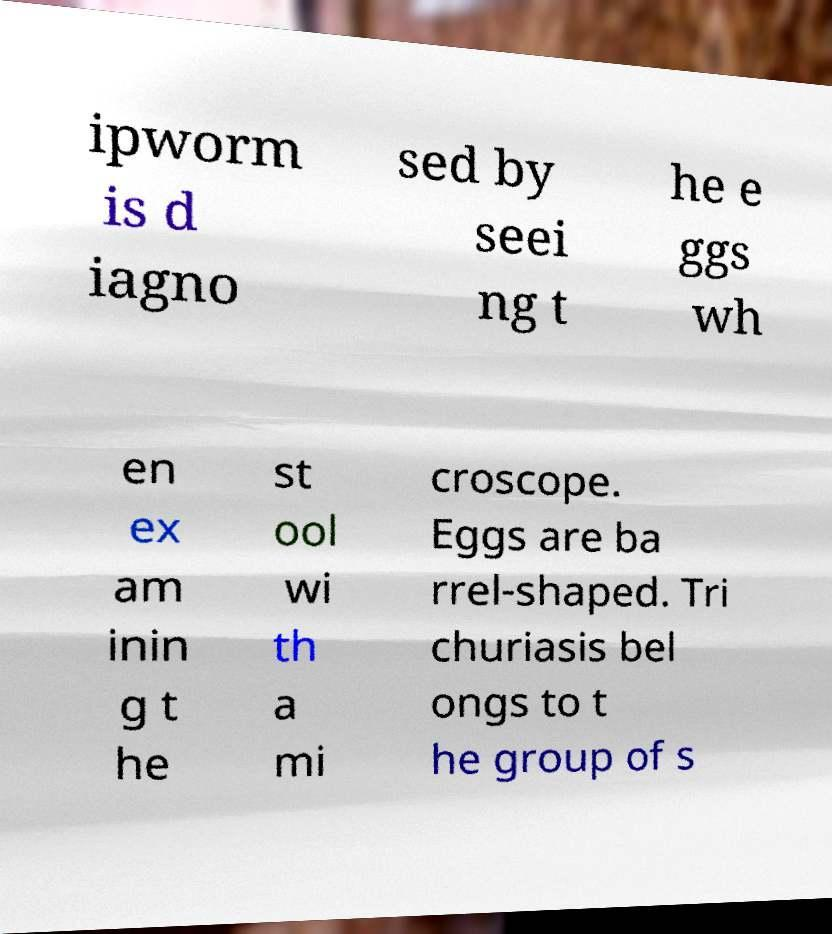For documentation purposes, I need the text within this image transcribed. Could you provide that? ipworm is d iagno sed by seei ng t he e ggs wh en ex am inin g t he st ool wi th a mi croscope. Eggs are ba rrel-shaped. Tri churiasis bel ongs to t he group of s 